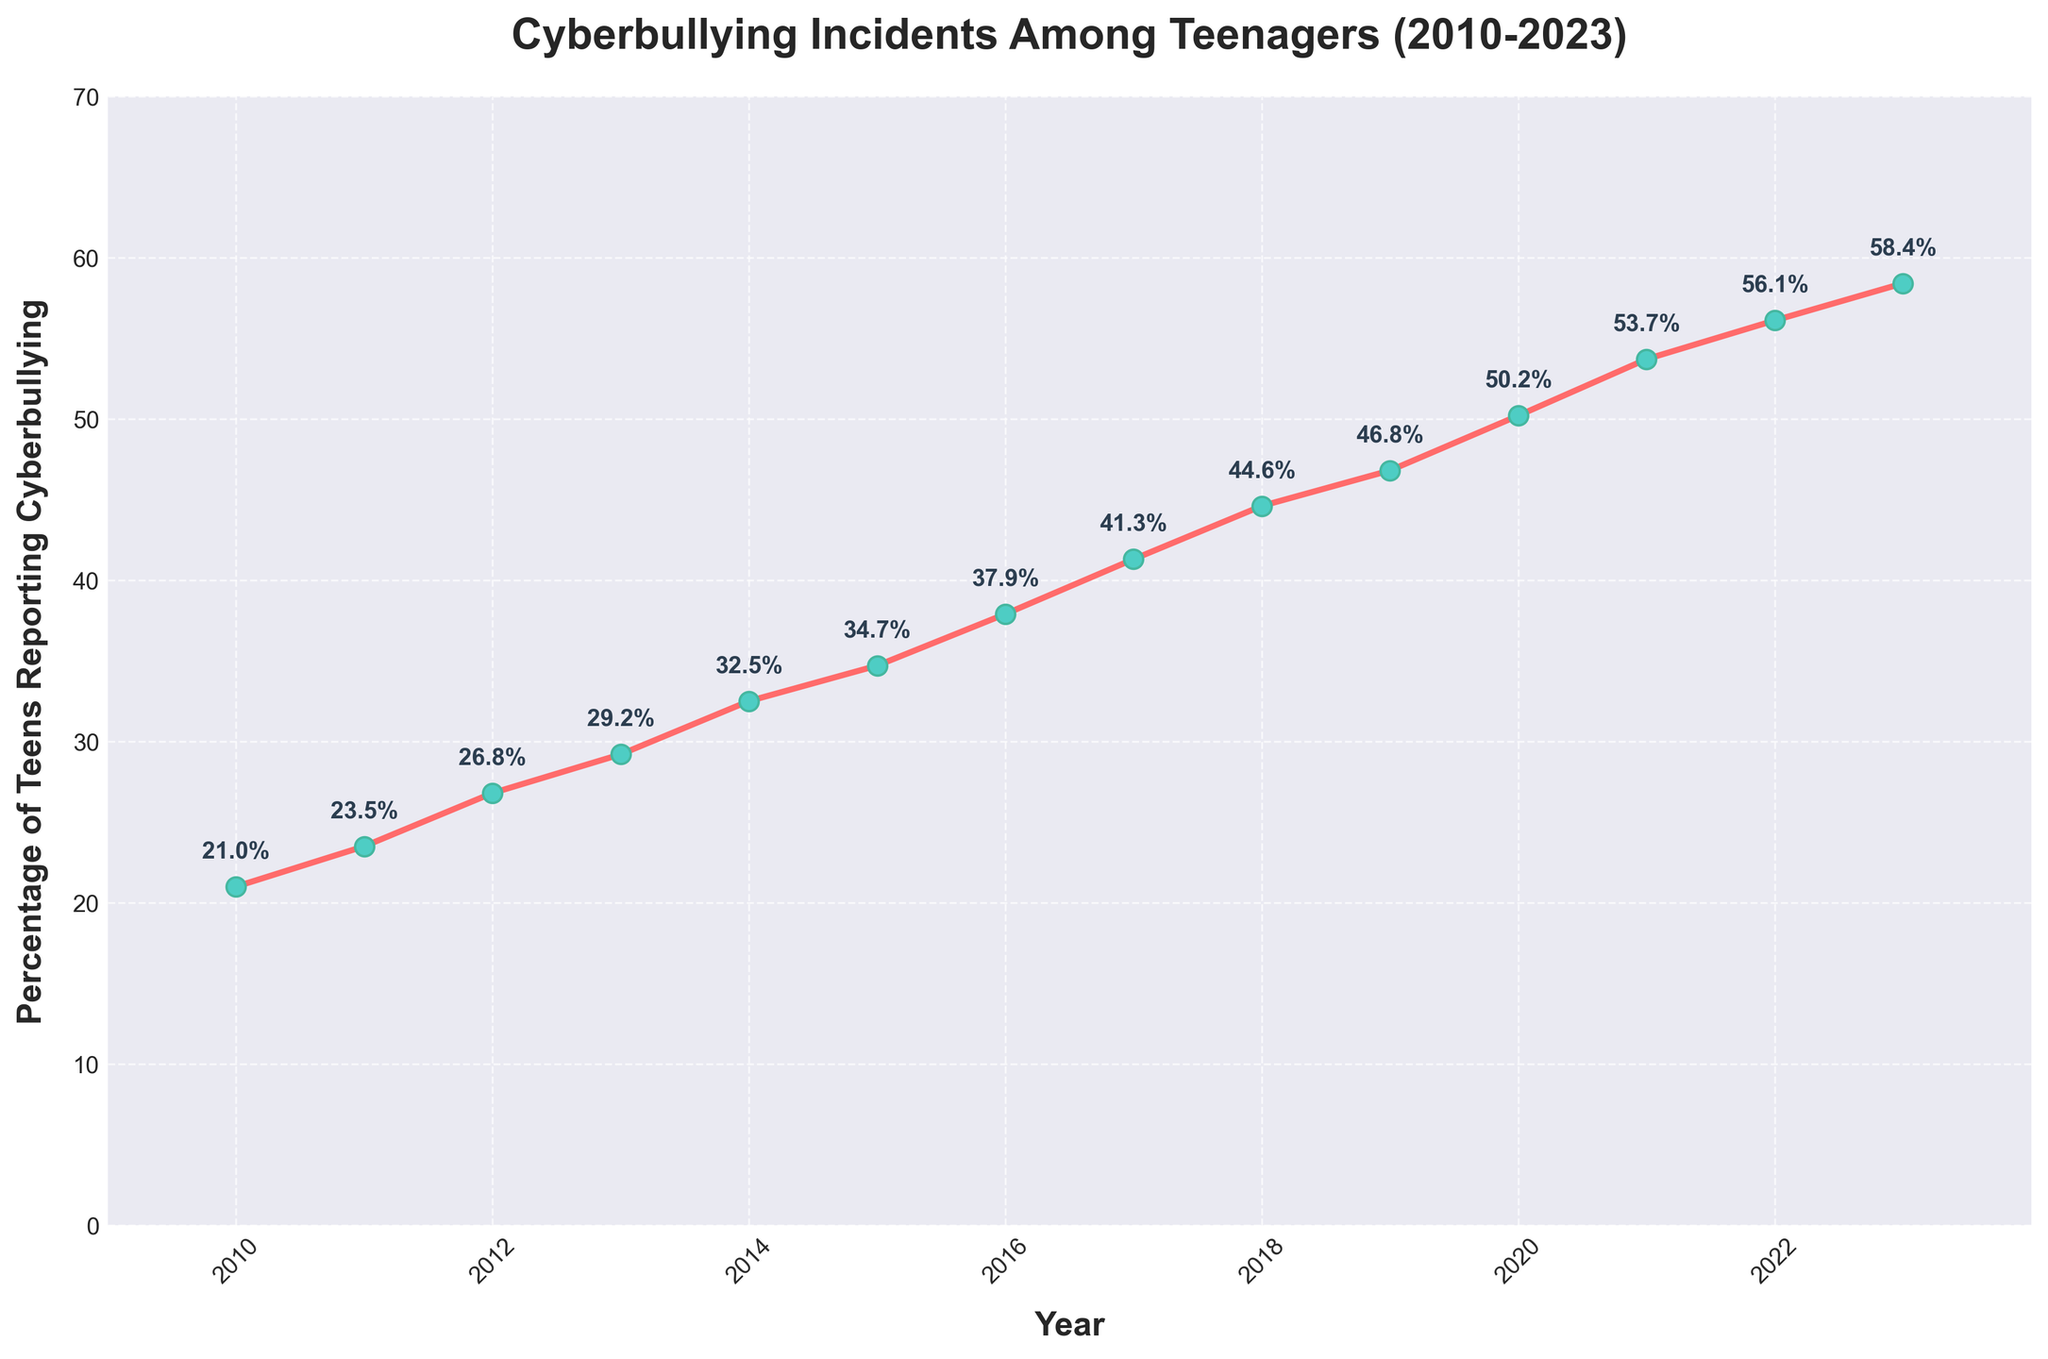What was the percentage increase in cyberbullying incidents from 2010 to 2023? To find the percentage increase, subtract the initial value (2010) from the final value (2023) and then divide by the initial value. (58.4 - 21.0) / 21.0 ≈ 1.781, which is approximately 178%.
Answer: 178% In what year did the percentage of teens reporting cyberbullying first exceed 50%? Looking at the trend line, the percentage of teens reporting cyberbullying first exceeded 50% in the year 2020.
Answer: 2020 Which year experienced a greater increase in reported cyberbullying incidents, from 2014 to 2015 or from 2019 to 2020? Find the difference in percentage from 2014 to 2015 and from 2019 to 2020. 2014 to 2015: 34.7 - 32.5 = 2.2, 2019 to 2020: 50.2 - 46.8 = 3.4. The year 2019 to 2020 experienced a greater increase.
Answer: 2019 to 2020 What is the average annual percentage increase in cyberbullying incidents from 2010 to 2023? First, find the total increase in percentage from 2010 to 2023, which is 58.4 - 21.0 = 37.4. There are 13 years between 2010 and 2023. The average annual increase is 37.4 / 13 ≈ 2.877, approximately 2.88%.
Answer: 2.88% Does the rate of reported cyberbullying incidents show any sign of decline over the period from 2010 to 2023? Examining the trend line, there is a continuous upward trajectory with no downward or declining periods in the data provided. Therefore, no decline is present.
Answer: No What is the median percentage of teens reporting cyberbullying incidents over the period 2010 to 2023? To find the median, list the values in order and find the middle number. The ordered percentages are: 21.0, 23.5, 26.8, 29.2, 32.5, 34.7, 37.9, 41.3, 44.6, 46.8, 50.2, 53.7, 56.1, 58.4. The middle value, between the 7th and 8th elements, is (37.9 + 41.3)/2 = 39.6.
Answer: 39.6 How many times did the percentage increase by more than 3 percentage points compared to the previous year? Check each consecutive pair of years to see if the increase is greater than 3 percentage points: 2011-2012, 2012-2013, 2013-2014, 2015-2016, 2016-2017, and 2020-2021. There are 6 occasions in total.
Answer: 6 Which year shows the highest percentage of teens reporting cyberbullying? The year with the highest point on the line, representing the highest percentage of teens reporting cyberbullying, is 2023.
Answer: 2023 